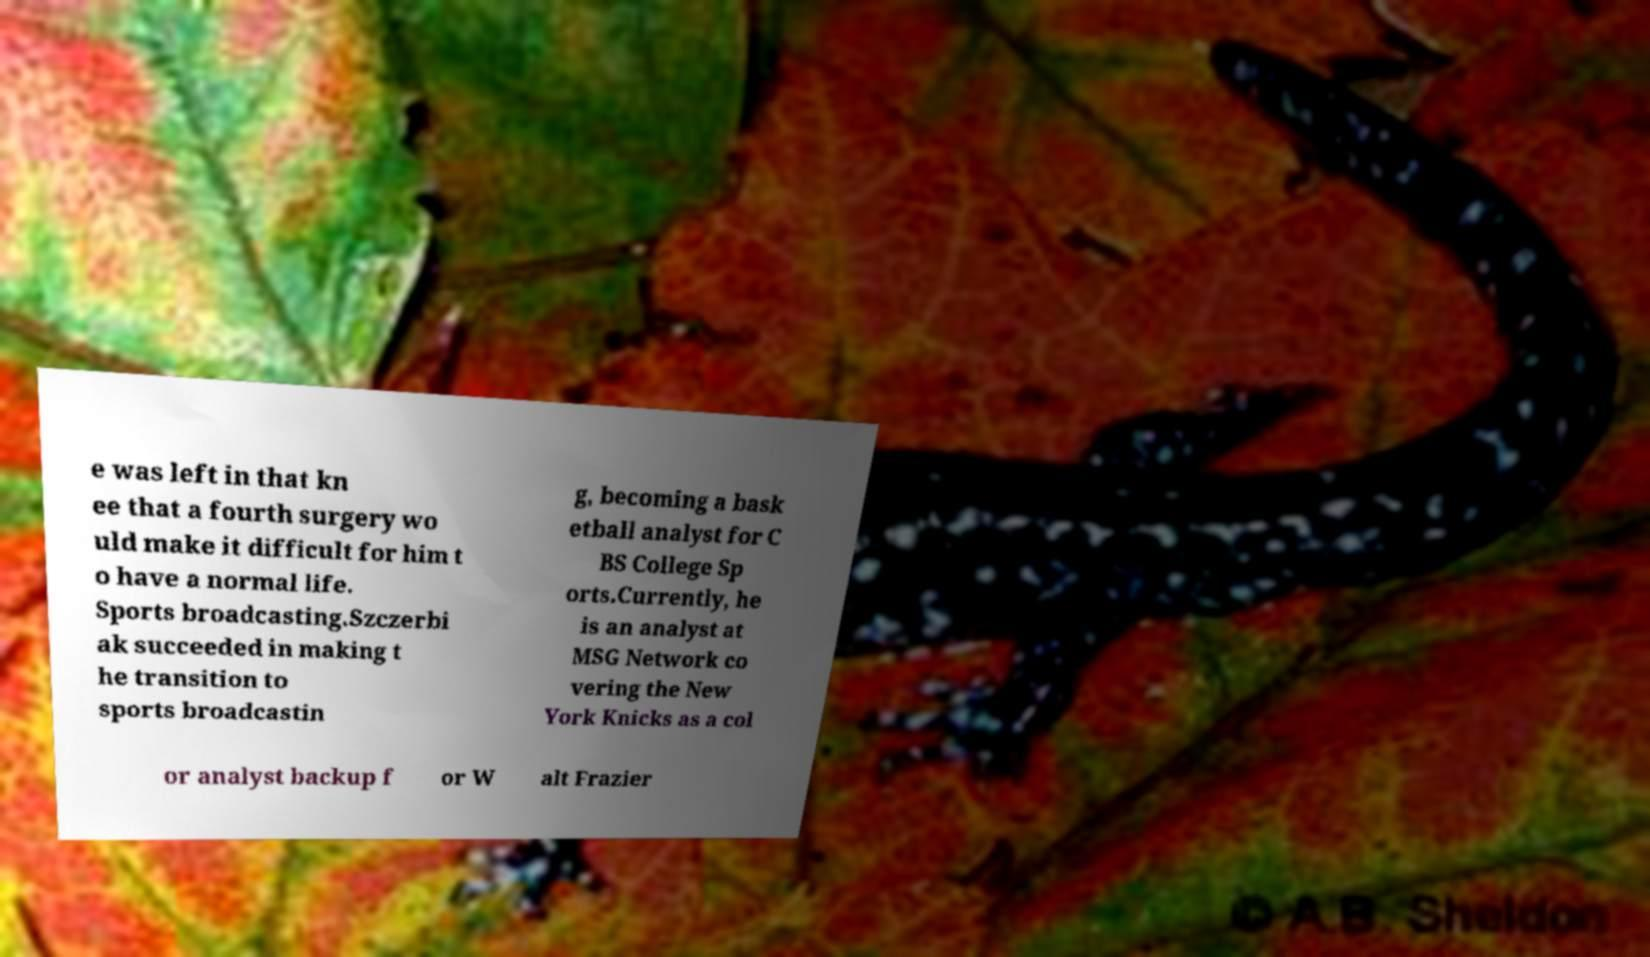Can you accurately transcribe the text from the provided image for me? e was left in that kn ee that a fourth surgery wo uld make it difficult for him t o have a normal life. Sports broadcasting.Szczerbi ak succeeded in making t he transition to sports broadcastin g, becoming a bask etball analyst for C BS College Sp orts.Currently, he is an analyst at MSG Network co vering the New York Knicks as a col or analyst backup f or W alt Frazier 